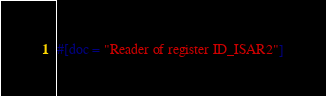<code> <loc_0><loc_0><loc_500><loc_500><_Rust_>#[doc = "Reader of register ID_ISAR2"]</code> 